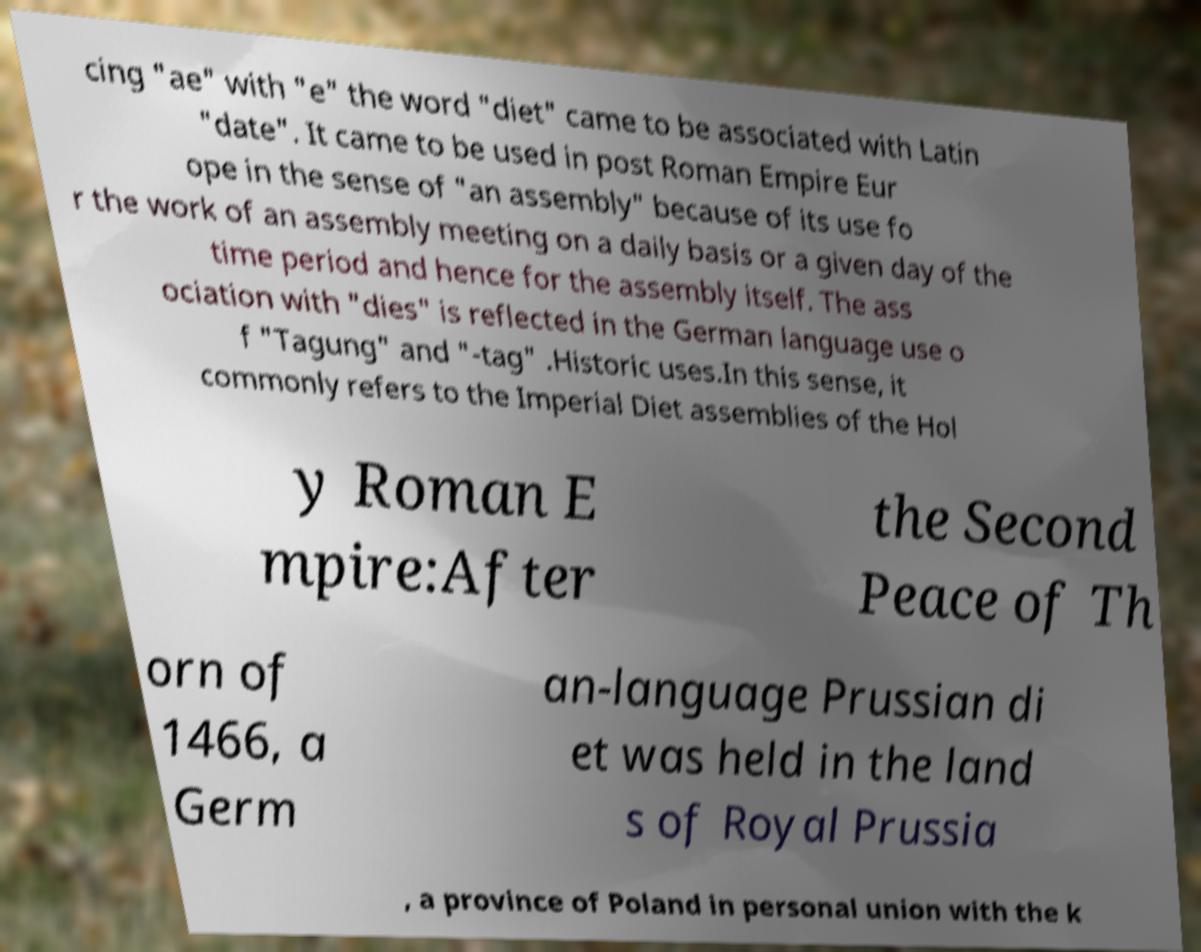I need the written content from this picture converted into text. Can you do that? cing "ae" with "e" the word "diet" came to be associated with Latin "date". It came to be used in post Roman Empire Eur ope in the sense of "an assembly" because of its use fo r the work of an assembly meeting on a daily basis or a given day of the time period and hence for the assembly itself. The ass ociation with "dies" is reflected in the German language use o f "Tagung" and "-tag" .Historic uses.In this sense, it commonly refers to the Imperial Diet assemblies of the Hol y Roman E mpire:After the Second Peace of Th orn of 1466, a Germ an-language Prussian di et was held in the land s of Royal Prussia , a province of Poland in personal union with the k 